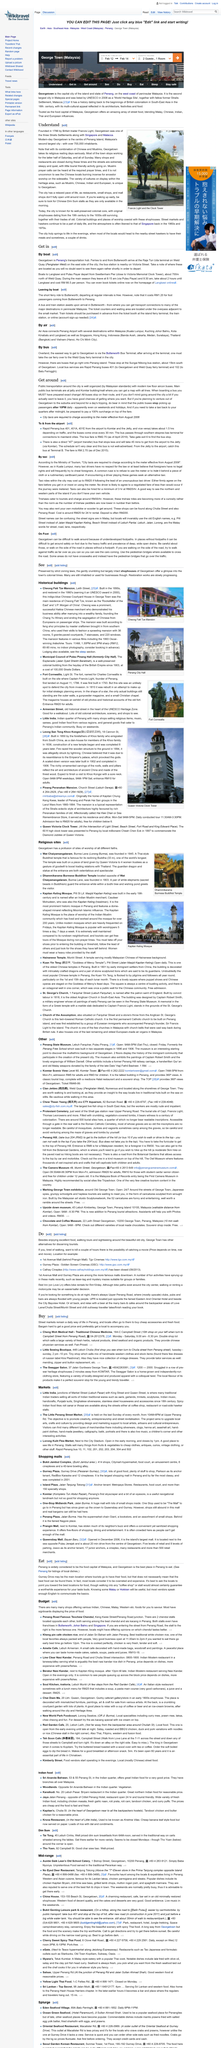Outline some significant characteristics in this image. Malaysia's second largest city is Georgetown. Air Asia provides convenient connections from Penang International Airport to various destinations within Malaysia, including Kuala Lumpur. Wat Chaiyamangalaram's reclining Buddha is 33 meters long. It is crucial to avoid being charged an excessive amount by an unscrupulous taxi driver by either insisting they use the meter or negotiating a fair and upfront price. The Amelie Cafe is decorated with hand-made bags, woodcraft, and paintings, creating a unique and visually appealing atmosphere for its customers. 